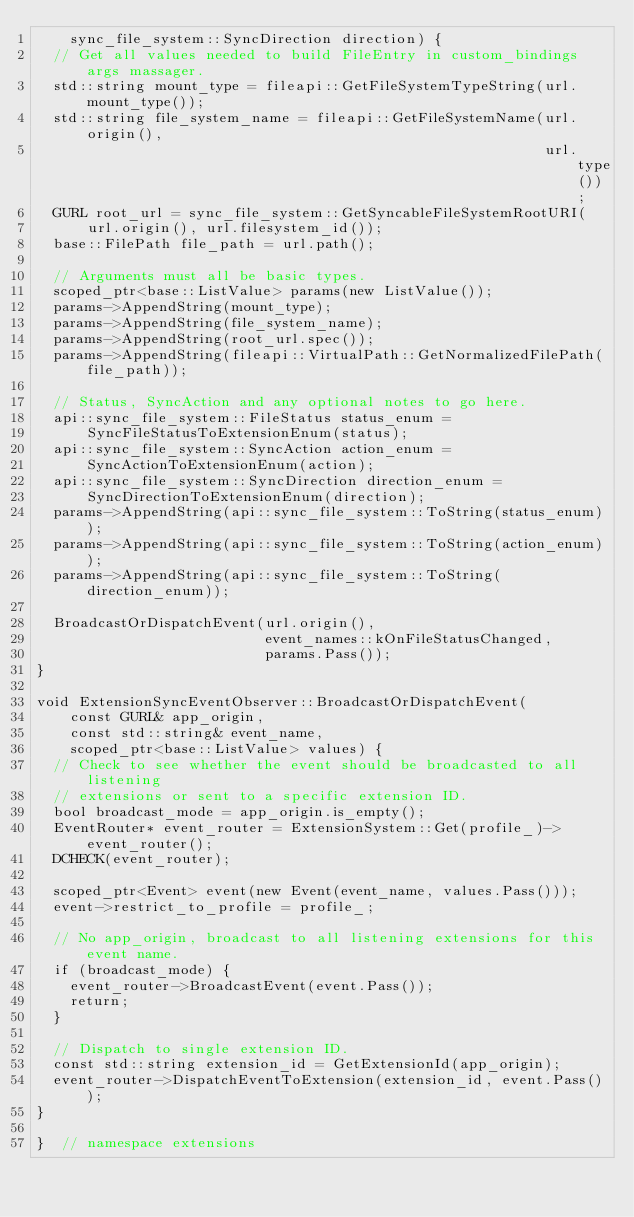Convert code to text. <code><loc_0><loc_0><loc_500><loc_500><_C++_>    sync_file_system::SyncDirection direction) {
  // Get all values needed to build FileEntry in custom_bindings args massager.
  std::string mount_type = fileapi::GetFileSystemTypeString(url.mount_type());
  std::string file_system_name = fileapi::GetFileSystemName(url.origin(),
                                                            url.type());
  GURL root_url = sync_file_system::GetSyncableFileSystemRootURI(
      url.origin(), url.filesystem_id());
  base::FilePath file_path = url.path();

  // Arguments must all be basic types.
  scoped_ptr<base::ListValue> params(new ListValue());
  params->AppendString(mount_type);
  params->AppendString(file_system_name);
  params->AppendString(root_url.spec());
  params->AppendString(fileapi::VirtualPath::GetNormalizedFilePath(file_path));

  // Status, SyncAction and any optional notes to go here.
  api::sync_file_system::FileStatus status_enum =
      SyncFileStatusToExtensionEnum(status);
  api::sync_file_system::SyncAction action_enum =
      SyncActionToExtensionEnum(action);
  api::sync_file_system::SyncDirection direction_enum =
      SyncDirectionToExtensionEnum(direction);
  params->AppendString(api::sync_file_system::ToString(status_enum));
  params->AppendString(api::sync_file_system::ToString(action_enum));
  params->AppendString(api::sync_file_system::ToString(direction_enum));

  BroadcastOrDispatchEvent(url.origin(),
                           event_names::kOnFileStatusChanged,
                           params.Pass());
}

void ExtensionSyncEventObserver::BroadcastOrDispatchEvent(
    const GURL& app_origin,
    const std::string& event_name,
    scoped_ptr<base::ListValue> values) {
  // Check to see whether the event should be broadcasted to all listening
  // extensions or sent to a specific extension ID.
  bool broadcast_mode = app_origin.is_empty();
  EventRouter* event_router = ExtensionSystem::Get(profile_)->event_router();
  DCHECK(event_router);

  scoped_ptr<Event> event(new Event(event_name, values.Pass()));
  event->restrict_to_profile = profile_;

  // No app_origin, broadcast to all listening extensions for this event name.
  if (broadcast_mode) {
    event_router->BroadcastEvent(event.Pass());
    return;
  }

  // Dispatch to single extension ID.
  const std::string extension_id = GetExtensionId(app_origin);
  event_router->DispatchEventToExtension(extension_id, event.Pass());
}

}  // namespace extensions
</code> 